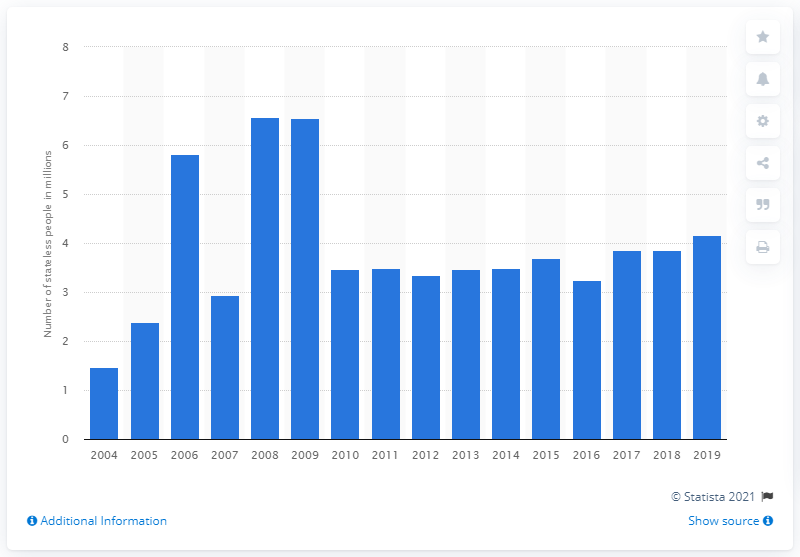Outline some significant characteristics in this image. In 2019, approximately 4.16 people were not holders of citizenship. 